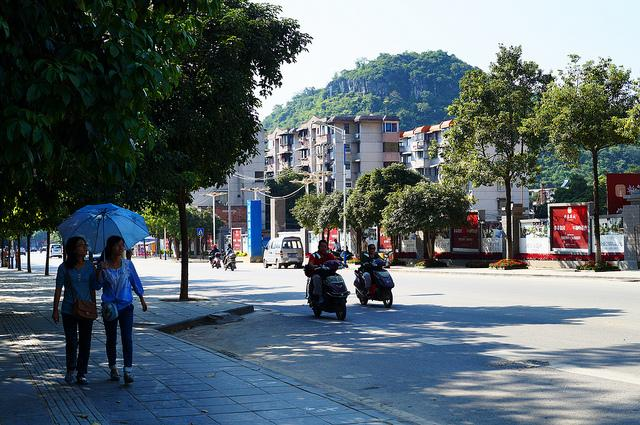What protection does an umbrella offer here? shade 